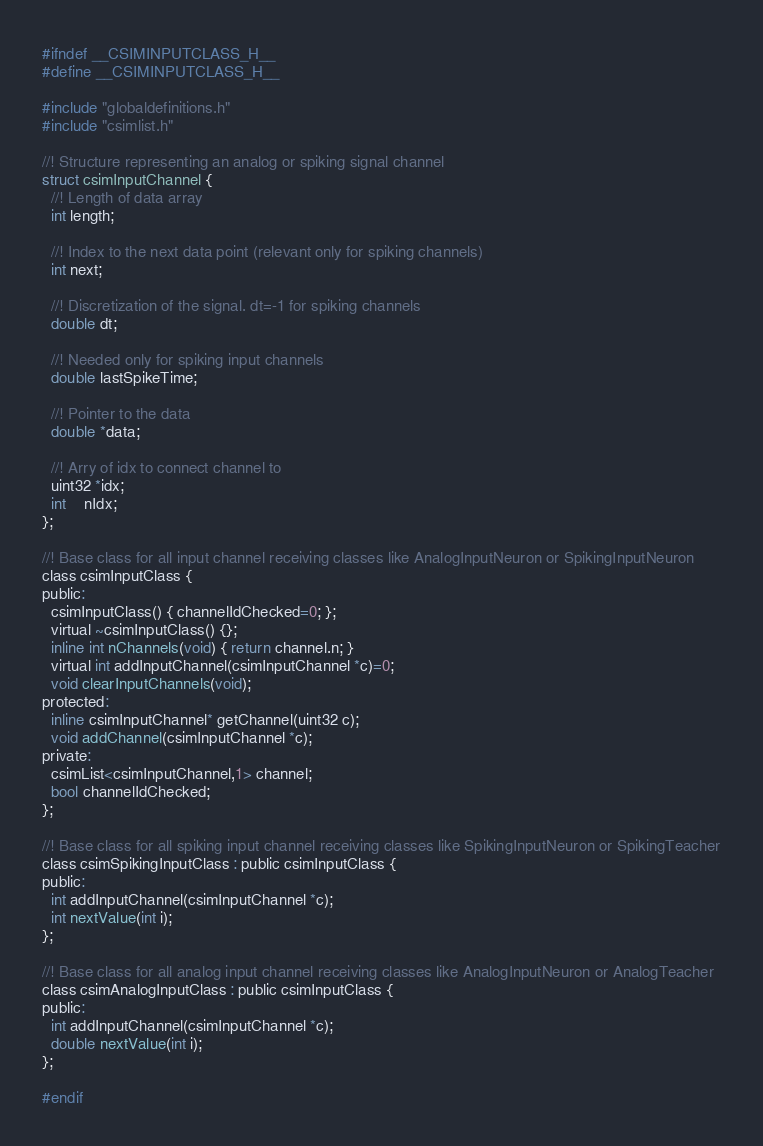<code> <loc_0><loc_0><loc_500><loc_500><_C_>#ifndef __CSIMINPUTCLASS_H__
#define __CSIMINPUTCLASS_H__

#include "globaldefinitions.h"
#include "csimlist.h"

//! Structure representing an analog or spiking signal channel
struct csimInputChannel {
  //! Length of data array
  int length;

  //! Index to the next data point (relevant only for spiking channels)
  int next;

  //! Discretization of the signal. dt=-1 for spiking channels
  double dt;

  //! Needed only for spiking input channels
  double lastSpikeTime;

  //! Pointer to the data
  double *data;

  //! Arry of idx to connect channel to
  uint32 *idx;
  int    nIdx;
};

//! Base class for all input channel receiving classes like AnalogInputNeuron or SpikingInputNeuron
class csimInputClass {
public:
  csimInputClass() { channelIdChecked=0; };
  virtual ~csimInputClass() {};
  inline int nChannels(void) { return channel.n; }
  virtual int addInputChannel(csimInputChannel *c)=0;
  void clearInputChannels(void);
protected:
  inline csimInputChannel* getChannel(uint32 c);
  void addChannel(csimInputChannel *c);
private:
  csimList<csimInputChannel,1> channel;
  bool channelIdChecked;
};

//! Base class for all spiking input channel receiving classes like SpikingInputNeuron or SpikingTeacher
class csimSpikingInputClass : public csimInputClass {
public:
  int addInputChannel(csimInputChannel *c);
  int nextValue(int i);
};

//! Base class for all analog input channel receiving classes like AnalogInputNeuron or AnalogTeacher
class csimAnalogInputClass : public csimInputClass {
public:
  int addInputChannel(csimInputChannel *c);
  double nextValue(int i);
};

#endif
</code> 